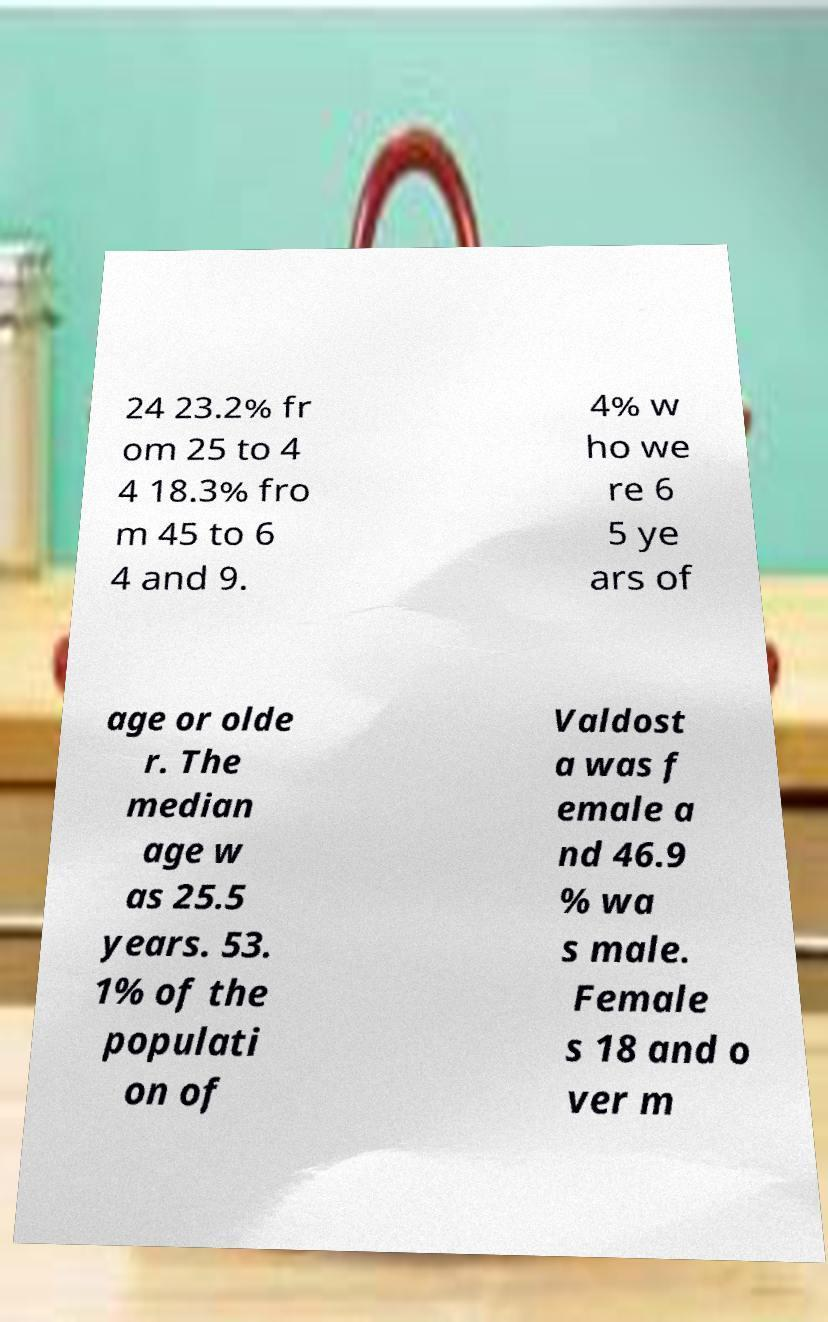Can you accurately transcribe the text from the provided image for me? 24 23.2% fr om 25 to 4 4 18.3% fro m 45 to 6 4 and 9. 4% w ho we re 6 5 ye ars of age or olde r. The median age w as 25.5 years. 53. 1% of the populati on of Valdost a was f emale a nd 46.9 % wa s male. Female s 18 and o ver m 